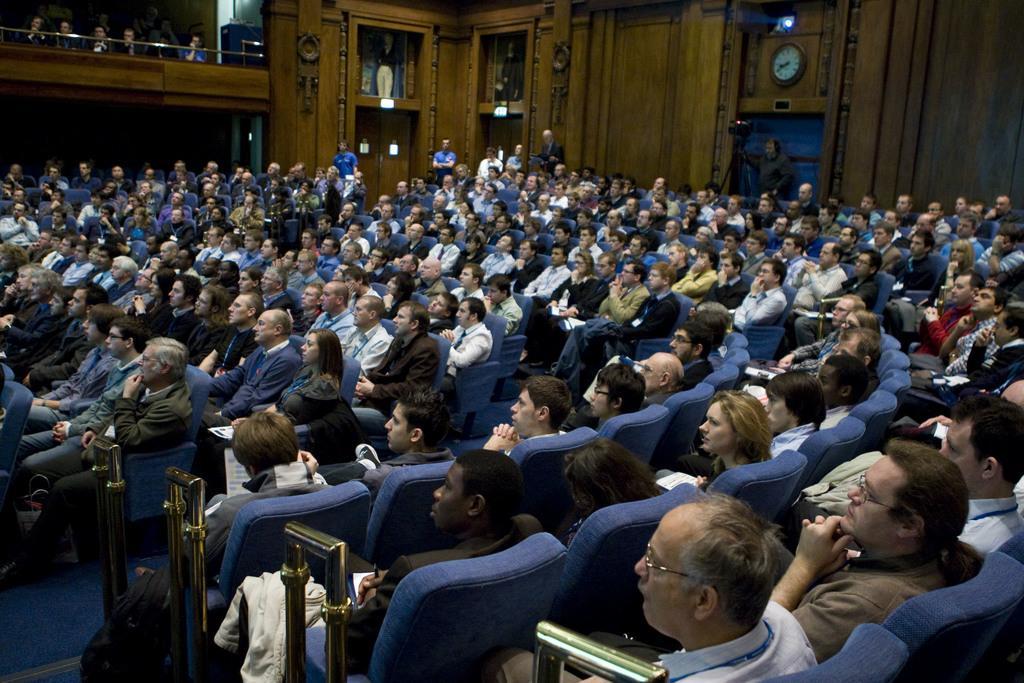How would you summarize this image in a sentence or two? This picture is clicked inside the hall and we can see the group of people sitting on the chairs. In the background we can see the wall, clock hanging on the wall, we can see the group of people standing and we can see the camera is attached to the stand and we can see the objects which seems to be the mannequins and we can see many other objects. 